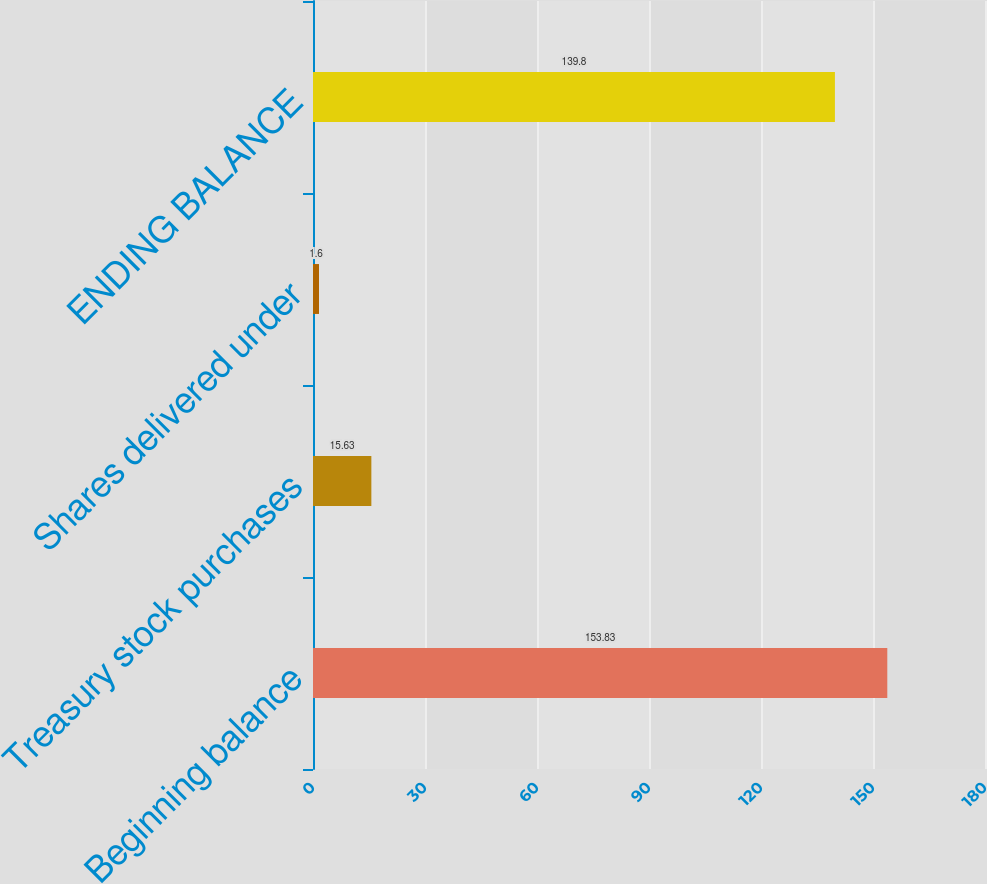Convert chart to OTSL. <chart><loc_0><loc_0><loc_500><loc_500><bar_chart><fcel>Beginning balance<fcel>Treasury stock purchases<fcel>Shares delivered under<fcel>ENDING BALANCE<nl><fcel>153.83<fcel>15.63<fcel>1.6<fcel>139.8<nl></chart> 